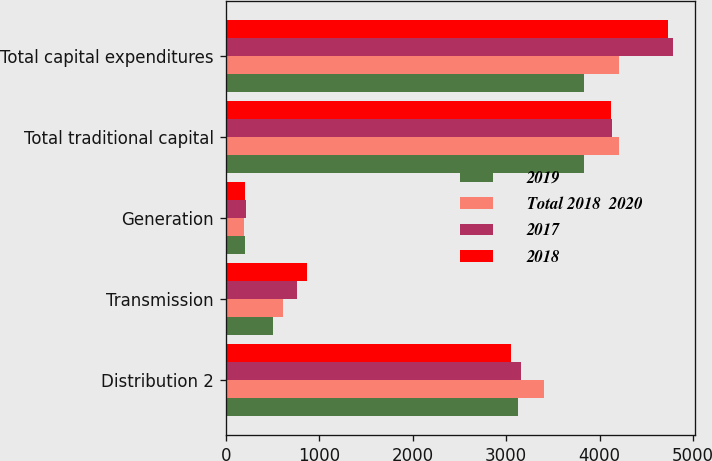<chart> <loc_0><loc_0><loc_500><loc_500><stacked_bar_chart><ecel><fcel>Distribution 2<fcel>Transmission<fcel>Generation<fcel>Total traditional capital<fcel>Total capital expenditures<nl><fcel>2019<fcel>3131<fcel>501<fcel>203<fcel>3835<fcel>3835<nl><fcel>Total 2018  2020<fcel>3399<fcel>609<fcel>193<fcel>4201<fcel>4201<nl><fcel>2017<fcel>3161<fcel>762<fcel>212<fcel>4135<fcel>4784<nl><fcel>2018<fcel>3048<fcel>874<fcel>201<fcel>4123<fcel>4731<nl></chart> 